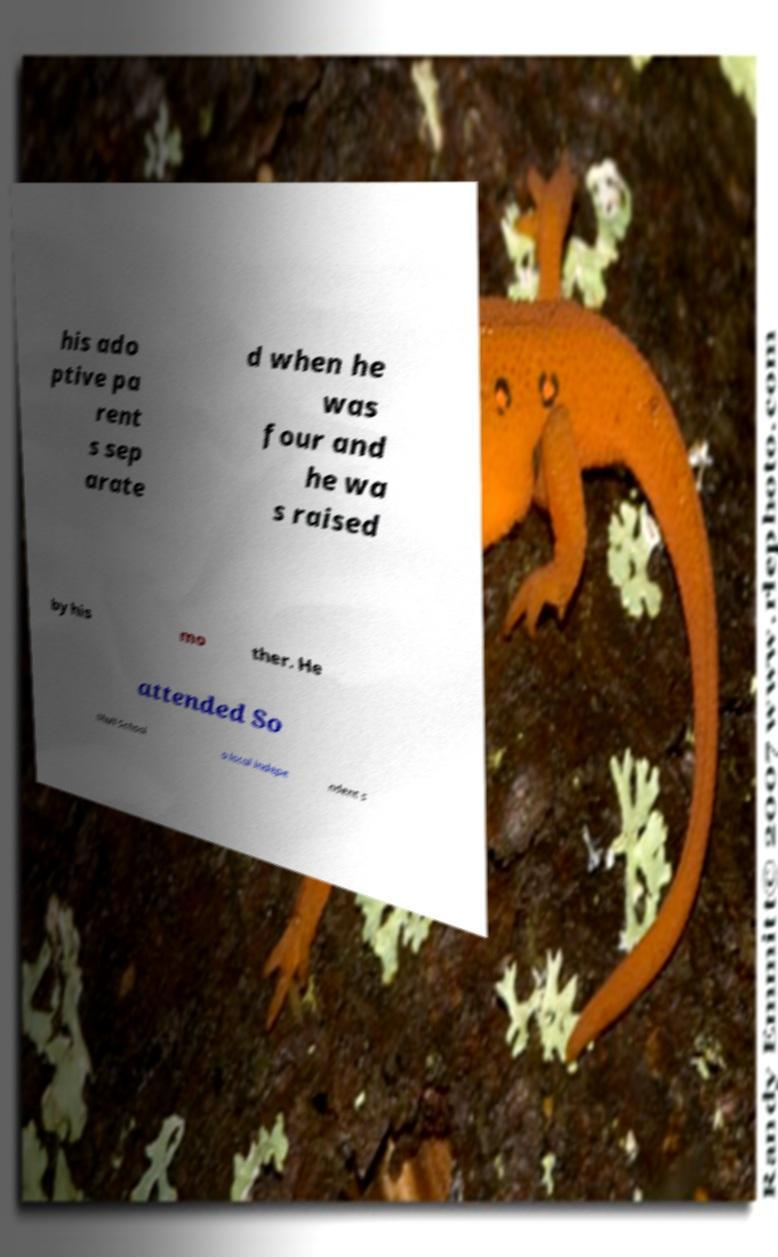Can you accurately transcribe the text from the provided image for me? his ado ptive pa rent s sep arate d when he was four and he wa s raised by his mo ther. He attended So lihull School a local indepe ndent s 